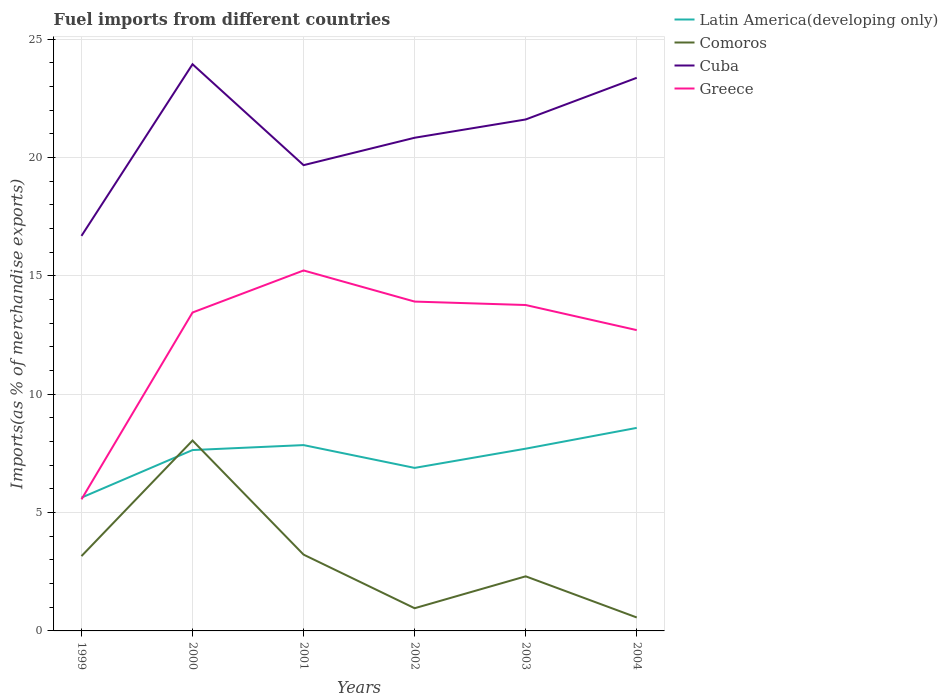How many different coloured lines are there?
Your response must be concise. 4. Does the line corresponding to Greece intersect with the line corresponding to Comoros?
Offer a terse response. No. Is the number of lines equal to the number of legend labels?
Offer a very short reply. Yes. Across all years, what is the maximum percentage of imports to different countries in Latin America(developing only)?
Offer a very short reply. 5.63. What is the total percentage of imports to different countries in Cuba in the graph?
Ensure brevity in your answer.  -1.16. What is the difference between the highest and the second highest percentage of imports to different countries in Greece?
Offer a terse response. 9.67. How many years are there in the graph?
Offer a terse response. 6. Where does the legend appear in the graph?
Provide a succinct answer. Top right. How many legend labels are there?
Make the answer very short. 4. What is the title of the graph?
Give a very brief answer. Fuel imports from different countries. Does "St. Vincent and the Grenadines" appear as one of the legend labels in the graph?
Provide a short and direct response. No. What is the label or title of the Y-axis?
Keep it short and to the point. Imports(as % of merchandise exports). What is the Imports(as % of merchandise exports) in Latin America(developing only) in 1999?
Your answer should be very brief. 5.63. What is the Imports(as % of merchandise exports) of Comoros in 1999?
Offer a terse response. 3.16. What is the Imports(as % of merchandise exports) in Cuba in 1999?
Your answer should be very brief. 16.69. What is the Imports(as % of merchandise exports) in Greece in 1999?
Offer a very short reply. 5.56. What is the Imports(as % of merchandise exports) of Latin America(developing only) in 2000?
Your answer should be compact. 7.64. What is the Imports(as % of merchandise exports) of Comoros in 2000?
Offer a terse response. 8.04. What is the Imports(as % of merchandise exports) of Cuba in 2000?
Give a very brief answer. 23.94. What is the Imports(as % of merchandise exports) of Greece in 2000?
Offer a terse response. 13.45. What is the Imports(as % of merchandise exports) in Latin America(developing only) in 2001?
Your answer should be compact. 7.85. What is the Imports(as % of merchandise exports) in Comoros in 2001?
Offer a terse response. 3.22. What is the Imports(as % of merchandise exports) of Cuba in 2001?
Provide a succinct answer. 19.68. What is the Imports(as % of merchandise exports) of Greece in 2001?
Your answer should be very brief. 15.23. What is the Imports(as % of merchandise exports) of Latin America(developing only) in 2002?
Keep it short and to the point. 6.89. What is the Imports(as % of merchandise exports) in Comoros in 2002?
Provide a short and direct response. 0.96. What is the Imports(as % of merchandise exports) in Cuba in 2002?
Your answer should be compact. 20.84. What is the Imports(as % of merchandise exports) in Greece in 2002?
Give a very brief answer. 13.91. What is the Imports(as % of merchandise exports) of Latin America(developing only) in 2003?
Your response must be concise. 7.7. What is the Imports(as % of merchandise exports) of Comoros in 2003?
Keep it short and to the point. 2.31. What is the Imports(as % of merchandise exports) in Cuba in 2003?
Offer a very short reply. 21.61. What is the Imports(as % of merchandise exports) of Greece in 2003?
Provide a short and direct response. 13.77. What is the Imports(as % of merchandise exports) in Latin America(developing only) in 2004?
Your answer should be very brief. 8.58. What is the Imports(as % of merchandise exports) in Comoros in 2004?
Make the answer very short. 0.57. What is the Imports(as % of merchandise exports) of Cuba in 2004?
Offer a very short reply. 23.37. What is the Imports(as % of merchandise exports) in Greece in 2004?
Provide a succinct answer. 12.71. Across all years, what is the maximum Imports(as % of merchandise exports) in Latin America(developing only)?
Ensure brevity in your answer.  8.58. Across all years, what is the maximum Imports(as % of merchandise exports) of Comoros?
Give a very brief answer. 8.04. Across all years, what is the maximum Imports(as % of merchandise exports) in Cuba?
Keep it short and to the point. 23.94. Across all years, what is the maximum Imports(as % of merchandise exports) of Greece?
Your answer should be compact. 15.23. Across all years, what is the minimum Imports(as % of merchandise exports) in Latin America(developing only)?
Your response must be concise. 5.63. Across all years, what is the minimum Imports(as % of merchandise exports) of Comoros?
Provide a short and direct response. 0.57. Across all years, what is the minimum Imports(as % of merchandise exports) of Cuba?
Keep it short and to the point. 16.69. Across all years, what is the minimum Imports(as % of merchandise exports) of Greece?
Your response must be concise. 5.56. What is the total Imports(as % of merchandise exports) of Latin America(developing only) in the graph?
Make the answer very short. 44.29. What is the total Imports(as % of merchandise exports) in Comoros in the graph?
Offer a very short reply. 18.26. What is the total Imports(as % of merchandise exports) in Cuba in the graph?
Offer a terse response. 126.12. What is the total Imports(as % of merchandise exports) of Greece in the graph?
Offer a terse response. 74.63. What is the difference between the Imports(as % of merchandise exports) in Latin America(developing only) in 1999 and that in 2000?
Your answer should be compact. -2.01. What is the difference between the Imports(as % of merchandise exports) of Comoros in 1999 and that in 2000?
Your answer should be compact. -4.88. What is the difference between the Imports(as % of merchandise exports) in Cuba in 1999 and that in 2000?
Keep it short and to the point. -7.25. What is the difference between the Imports(as % of merchandise exports) in Greece in 1999 and that in 2000?
Ensure brevity in your answer.  -7.89. What is the difference between the Imports(as % of merchandise exports) of Latin America(developing only) in 1999 and that in 2001?
Offer a very short reply. -2.22. What is the difference between the Imports(as % of merchandise exports) of Comoros in 1999 and that in 2001?
Your answer should be very brief. -0.06. What is the difference between the Imports(as % of merchandise exports) in Cuba in 1999 and that in 2001?
Keep it short and to the point. -2.99. What is the difference between the Imports(as % of merchandise exports) in Greece in 1999 and that in 2001?
Your answer should be very brief. -9.67. What is the difference between the Imports(as % of merchandise exports) of Latin America(developing only) in 1999 and that in 2002?
Provide a succinct answer. -1.26. What is the difference between the Imports(as % of merchandise exports) in Comoros in 1999 and that in 2002?
Make the answer very short. 2.2. What is the difference between the Imports(as % of merchandise exports) of Cuba in 1999 and that in 2002?
Your answer should be very brief. -4.15. What is the difference between the Imports(as % of merchandise exports) in Greece in 1999 and that in 2002?
Give a very brief answer. -8.36. What is the difference between the Imports(as % of merchandise exports) in Latin America(developing only) in 1999 and that in 2003?
Offer a very short reply. -2.07. What is the difference between the Imports(as % of merchandise exports) of Comoros in 1999 and that in 2003?
Keep it short and to the point. 0.85. What is the difference between the Imports(as % of merchandise exports) of Cuba in 1999 and that in 2003?
Give a very brief answer. -4.92. What is the difference between the Imports(as % of merchandise exports) of Greece in 1999 and that in 2003?
Offer a very short reply. -8.21. What is the difference between the Imports(as % of merchandise exports) in Latin America(developing only) in 1999 and that in 2004?
Provide a succinct answer. -2.95. What is the difference between the Imports(as % of merchandise exports) in Comoros in 1999 and that in 2004?
Make the answer very short. 2.59. What is the difference between the Imports(as % of merchandise exports) in Cuba in 1999 and that in 2004?
Provide a succinct answer. -6.68. What is the difference between the Imports(as % of merchandise exports) in Greece in 1999 and that in 2004?
Your response must be concise. -7.15. What is the difference between the Imports(as % of merchandise exports) of Latin America(developing only) in 2000 and that in 2001?
Provide a short and direct response. -0.21. What is the difference between the Imports(as % of merchandise exports) of Comoros in 2000 and that in 2001?
Keep it short and to the point. 4.82. What is the difference between the Imports(as % of merchandise exports) in Cuba in 2000 and that in 2001?
Make the answer very short. 4.26. What is the difference between the Imports(as % of merchandise exports) in Greece in 2000 and that in 2001?
Offer a very short reply. -1.78. What is the difference between the Imports(as % of merchandise exports) in Latin America(developing only) in 2000 and that in 2002?
Offer a very short reply. 0.75. What is the difference between the Imports(as % of merchandise exports) in Comoros in 2000 and that in 2002?
Offer a very short reply. 7.08. What is the difference between the Imports(as % of merchandise exports) in Cuba in 2000 and that in 2002?
Offer a very short reply. 3.11. What is the difference between the Imports(as % of merchandise exports) in Greece in 2000 and that in 2002?
Your answer should be compact. -0.46. What is the difference between the Imports(as % of merchandise exports) of Latin America(developing only) in 2000 and that in 2003?
Provide a succinct answer. -0.06. What is the difference between the Imports(as % of merchandise exports) of Comoros in 2000 and that in 2003?
Provide a succinct answer. 5.74. What is the difference between the Imports(as % of merchandise exports) of Cuba in 2000 and that in 2003?
Make the answer very short. 2.33. What is the difference between the Imports(as % of merchandise exports) of Greece in 2000 and that in 2003?
Offer a terse response. -0.32. What is the difference between the Imports(as % of merchandise exports) of Latin America(developing only) in 2000 and that in 2004?
Provide a succinct answer. -0.94. What is the difference between the Imports(as % of merchandise exports) of Comoros in 2000 and that in 2004?
Provide a succinct answer. 7.47. What is the difference between the Imports(as % of merchandise exports) of Cuba in 2000 and that in 2004?
Offer a terse response. 0.57. What is the difference between the Imports(as % of merchandise exports) of Greece in 2000 and that in 2004?
Ensure brevity in your answer.  0.74. What is the difference between the Imports(as % of merchandise exports) in Latin America(developing only) in 2001 and that in 2002?
Provide a succinct answer. 0.96. What is the difference between the Imports(as % of merchandise exports) of Comoros in 2001 and that in 2002?
Give a very brief answer. 2.26. What is the difference between the Imports(as % of merchandise exports) of Cuba in 2001 and that in 2002?
Make the answer very short. -1.16. What is the difference between the Imports(as % of merchandise exports) in Greece in 2001 and that in 2002?
Your answer should be very brief. 1.31. What is the difference between the Imports(as % of merchandise exports) in Latin America(developing only) in 2001 and that in 2003?
Provide a short and direct response. 0.15. What is the difference between the Imports(as % of merchandise exports) in Comoros in 2001 and that in 2003?
Your answer should be compact. 0.92. What is the difference between the Imports(as % of merchandise exports) in Cuba in 2001 and that in 2003?
Your answer should be compact. -1.93. What is the difference between the Imports(as % of merchandise exports) of Greece in 2001 and that in 2003?
Provide a succinct answer. 1.46. What is the difference between the Imports(as % of merchandise exports) of Latin America(developing only) in 2001 and that in 2004?
Ensure brevity in your answer.  -0.73. What is the difference between the Imports(as % of merchandise exports) in Comoros in 2001 and that in 2004?
Your answer should be compact. 2.65. What is the difference between the Imports(as % of merchandise exports) of Cuba in 2001 and that in 2004?
Provide a succinct answer. -3.69. What is the difference between the Imports(as % of merchandise exports) in Greece in 2001 and that in 2004?
Offer a terse response. 2.52. What is the difference between the Imports(as % of merchandise exports) of Latin America(developing only) in 2002 and that in 2003?
Your response must be concise. -0.81. What is the difference between the Imports(as % of merchandise exports) of Comoros in 2002 and that in 2003?
Ensure brevity in your answer.  -1.35. What is the difference between the Imports(as % of merchandise exports) of Cuba in 2002 and that in 2003?
Your answer should be very brief. -0.77. What is the difference between the Imports(as % of merchandise exports) in Greece in 2002 and that in 2003?
Offer a terse response. 0.15. What is the difference between the Imports(as % of merchandise exports) in Latin America(developing only) in 2002 and that in 2004?
Your answer should be very brief. -1.69. What is the difference between the Imports(as % of merchandise exports) in Comoros in 2002 and that in 2004?
Make the answer very short. 0.39. What is the difference between the Imports(as % of merchandise exports) in Cuba in 2002 and that in 2004?
Keep it short and to the point. -2.53. What is the difference between the Imports(as % of merchandise exports) in Greece in 2002 and that in 2004?
Your answer should be very brief. 1.21. What is the difference between the Imports(as % of merchandise exports) in Latin America(developing only) in 2003 and that in 2004?
Offer a terse response. -0.88. What is the difference between the Imports(as % of merchandise exports) of Comoros in 2003 and that in 2004?
Make the answer very short. 1.74. What is the difference between the Imports(as % of merchandise exports) in Cuba in 2003 and that in 2004?
Offer a terse response. -1.76. What is the difference between the Imports(as % of merchandise exports) of Greece in 2003 and that in 2004?
Your answer should be compact. 1.06. What is the difference between the Imports(as % of merchandise exports) of Latin America(developing only) in 1999 and the Imports(as % of merchandise exports) of Comoros in 2000?
Provide a short and direct response. -2.41. What is the difference between the Imports(as % of merchandise exports) in Latin America(developing only) in 1999 and the Imports(as % of merchandise exports) in Cuba in 2000?
Give a very brief answer. -18.31. What is the difference between the Imports(as % of merchandise exports) in Latin America(developing only) in 1999 and the Imports(as % of merchandise exports) in Greece in 2000?
Your answer should be compact. -7.82. What is the difference between the Imports(as % of merchandise exports) in Comoros in 1999 and the Imports(as % of merchandise exports) in Cuba in 2000?
Keep it short and to the point. -20.78. What is the difference between the Imports(as % of merchandise exports) of Comoros in 1999 and the Imports(as % of merchandise exports) of Greece in 2000?
Give a very brief answer. -10.29. What is the difference between the Imports(as % of merchandise exports) of Cuba in 1999 and the Imports(as % of merchandise exports) of Greece in 2000?
Make the answer very short. 3.24. What is the difference between the Imports(as % of merchandise exports) of Latin America(developing only) in 1999 and the Imports(as % of merchandise exports) of Comoros in 2001?
Your response must be concise. 2.41. What is the difference between the Imports(as % of merchandise exports) in Latin America(developing only) in 1999 and the Imports(as % of merchandise exports) in Cuba in 2001?
Offer a very short reply. -14.05. What is the difference between the Imports(as % of merchandise exports) of Latin America(developing only) in 1999 and the Imports(as % of merchandise exports) of Greece in 2001?
Ensure brevity in your answer.  -9.6. What is the difference between the Imports(as % of merchandise exports) of Comoros in 1999 and the Imports(as % of merchandise exports) of Cuba in 2001?
Provide a short and direct response. -16.52. What is the difference between the Imports(as % of merchandise exports) in Comoros in 1999 and the Imports(as % of merchandise exports) in Greece in 2001?
Offer a very short reply. -12.07. What is the difference between the Imports(as % of merchandise exports) of Cuba in 1999 and the Imports(as % of merchandise exports) of Greece in 2001?
Your response must be concise. 1.46. What is the difference between the Imports(as % of merchandise exports) of Latin America(developing only) in 1999 and the Imports(as % of merchandise exports) of Comoros in 2002?
Offer a terse response. 4.67. What is the difference between the Imports(as % of merchandise exports) in Latin America(developing only) in 1999 and the Imports(as % of merchandise exports) in Cuba in 2002?
Give a very brief answer. -15.2. What is the difference between the Imports(as % of merchandise exports) in Latin America(developing only) in 1999 and the Imports(as % of merchandise exports) in Greece in 2002?
Your response must be concise. -8.28. What is the difference between the Imports(as % of merchandise exports) of Comoros in 1999 and the Imports(as % of merchandise exports) of Cuba in 2002?
Ensure brevity in your answer.  -17.67. What is the difference between the Imports(as % of merchandise exports) of Comoros in 1999 and the Imports(as % of merchandise exports) of Greece in 2002?
Offer a very short reply. -10.75. What is the difference between the Imports(as % of merchandise exports) of Cuba in 1999 and the Imports(as % of merchandise exports) of Greece in 2002?
Make the answer very short. 2.78. What is the difference between the Imports(as % of merchandise exports) of Latin America(developing only) in 1999 and the Imports(as % of merchandise exports) of Comoros in 2003?
Ensure brevity in your answer.  3.32. What is the difference between the Imports(as % of merchandise exports) in Latin America(developing only) in 1999 and the Imports(as % of merchandise exports) in Cuba in 2003?
Keep it short and to the point. -15.98. What is the difference between the Imports(as % of merchandise exports) of Latin America(developing only) in 1999 and the Imports(as % of merchandise exports) of Greece in 2003?
Make the answer very short. -8.14. What is the difference between the Imports(as % of merchandise exports) in Comoros in 1999 and the Imports(as % of merchandise exports) in Cuba in 2003?
Make the answer very short. -18.45. What is the difference between the Imports(as % of merchandise exports) in Comoros in 1999 and the Imports(as % of merchandise exports) in Greece in 2003?
Make the answer very short. -10.61. What is the difference between the Imports(as % of merchandise exports) in Cuba in 1999 and the Imports(as % of merchandise exports) in Greece in 2003?
Make the answer very short. 2.92. What is the difference between the Imports(as % of merchandise exports) of Latin America(developing only) in 1999 and the Imports(as % of merchandise exports) of Comoros in 2004?
Provide a succinct answer. 5.06. What is the difference between the Imports(as % of merchandise exports) of Latin America(developing only) in 1999 and the Imports(as % of merchandise exports) of Cuba in 2004?
Your answer should be very brief. -17.74. What is the difference between the Imports(as % of merchandise exports) of Latin America(developing only) in 1999 and the Imports(as % of merchandise exports) of Greece in 2004?
Your answer should be very brief. -7.08. What is the difference between the Imports(as % of merchandise exports) in Comoros in 1999 and the Imports(as % of merchandise exports) in Cuba in 2004?
Ensure brevity in your answer.  -20.21. What is the difference between the Imports(as % of merchandise exports) of Comoros in 1999 and the Imports(as % of merchandise exports) of Greece in 2004?
Ensure brevity in your answer.  -9.55. What is the difference between the Imports(as % of merchandise exports) of Cuba in 1999 and the Imports(as % of merchandise exports) of Greece in 2004?
Your answer should be compact. 3.98. What is the difference between the Imports(as % of merchandise exports) in Latin America(developing only) in 2000 and the Imports(as % of merchandise exports) in Comoros in 2001?
Offer a very short reply. 4.42. What is the difference between the Imports(as % of merchandise exports) in Latin America(developing only) in 2000 and the Imports(as % of merchandise exports) in Cuba in 2001?
Your answer should be very brief. -12.04. What is the difference between the Imports(as % of merchandise exports) of Latin America(developing only) in 2000 and the Imports(as % of merchandise exports) of Greece in 2001?
Keep it short and to the point. -7.59. What is the difference between the Imports(as % of merchandise exports) of Comoros in 2000 and the Imports(as % of merchandise exports) of Cuba in 2001?
Keep it short and to the point. -11.63. What is the difference between the Imports(as % of merchandise exports) of Comoros in 2000 and the Imports(as % of merchandise exports) of Greece in 2001?
Offer a terse response. -7.19. What is the difference between the Imports(as % of merchandise exports) of Cuba in 2000 and the Imports(as % of merchandise exports) of Greece in 2001?
Make the answer very short. 8.71. What is the difference between the Imports(as % of merchandise exports) of Latin America(developing only) in 2000 and the Imports(as % of merchandise exports) of Comoros in 2002?
Provide a short and direct response. 6.68. What is the difference between the Imports(as % of merchandise exports) of Latin America(developing only) in 2000 and the Imports(as % of merchandise exports) of Cuba in 2002?
Ensure brevity in your answer.  -13.19. What is the difference between the Imports(as % of merchandise exports) in Latin America(developing only) in 2000 and the Imports(as % of merchandise exports) in Greece in 2002?
Offer a very short reply. -6.27. What is the difference between the Imports(as % of merchandise exports) in Comoros in 2000 and the Imports(as % of merchandise exports) in Cuba in 2002?
Make the answer very short. -12.79. What is the difference between the Imports(as % of merchandise exports) of Comoros in 2000 and the Imports(as % of merchandise exports) of Greece in 2002?
Offer a very short reply. -5.87. What is the difference between the Imports(as % of merchandise exports) of Cuba in 2000 and the Imports(as % of merchandise exports) of Greece in 2002?
Make the answer very short. 10.03. What is the difference between the Imports(as % of merchandise exports) in Latin America(developing only) in 2000 and the Imports(as % of merchandise exports) in Comoros in 2003?
Offer a terse response. 5.33. What is the difference between the Imports(as % of merchandise exports) in Latin America(developing only) in 2000 and the Imports(as % of merchandise exports) in Cuba in 2003?
Ensure brevity in your answer.  -13.97. What is the difference between the Imports(as % of merchandise exports) of Latin America(developing only) in 2000 and the Imports(as % of merchandise exports) of Greece in 2003?
Offer a very short reply. -6.13. What is the difference between the Imports(as % of merchandise exports) in Comoros in 2000 and the Imports(as % of merchandise exports) in Cuba in 2003?
Keep it short and to the point. -13.57. What is the difference between the Imports(as % of merchandise exports) of Comoros in 2000 and the Imports(as % of merchandise exports) of Greece in 2003?
Provide a short and direct response. -5.73. What is the difference between the Imports(as % of merchandise exports) in Cuba in 2000 and the Imports(as % of merchandise exports) in Greece in 2003?
Provide a succinct answer. 10.17. What is the difference between the Imports(as % of merchandise exports) in Latin America(developing only) in 2000 and the Imports(as % of merchandise exports) in Comoros in 2004?
Your answer should be compact. 7.07. What is the difference between the Imports(as % of merchandise exports) of Latin America(developing only) in 2000 and the Imports(as % of merchandise exports) of Cuba in 2004?
Your response must be concise. -15.73. What is the difference between the Imports(as % of merchandise exports) in Latin America(developing only) in 2000 and the Imports(as % of merchandise exports) in Greece in 2004?
Your response must be concise. -5.07. What is the difference between the Imports(as % of merchandise exports) of Comoros in 2000 and the Imports(as % of merchandise exports) of Cuba in 2004?
Your answer should be very brief. -15.33. What is the difference between the Imports(as % of merchandise exports) of Comoros in 2000 and the Imports(as % of merchandise exports) of Greece in 2004?
Your answer should be very brief. -4.67. What is the difference between the Imports(as % of merchandise exports) in Cuba in 2000 and the Imports(as % of merchandise exports) in Greece in 2004?
Make the answer very short. 11.23. What is the difference between the Imports(as % of merchandise exports) of Latin America(developing only) in 2001 and the Imports(as % of merchandise exports) of Comoros in 2002?
Make the answer very short. 6.89. What is the difference between the Imports(as % of merchandise exports) of Latin America(developing only) in 2001 and the Imports(as % of merchandise exports) of Cuba in 2002?
Your answer should be very brief. -12.99. What is the difference between the Imports(as % of merchandise exports) in Latin America(developing only) in 2001 and the Imports(as % of merchandise exports) in Greece in 2002?
Your response must be concise. -6.06. What is the difference between the Imports(as % of merchandise exports) in Comoros in 2001 and the Imports(as % of merchandise exports) in Cuba in 2002?
Keep it short and to the point. -17.61. What is the difference between the Imports(as % of merchandise exports) in Comoros in 2001 and the Imports(as % of merchandise exports) in Greece in 2002?
Make the answer very short. -10.69. What is the difference between the Imports(as % of merchandise exports) of Cuba in 2001 and the Imports(as % of merchandise exports) of Greece in 2002?
Offer a terse response. 5.76. What is the difference between the Imports(as % of merchandise exports) in Latin America(developing only) in 2001 and the Imports(as % of merchandise exports) in Comoros in 2003?
Offer a very short reply. 5.54. What is the difference between the Imports(as % of merchandise exports) of Latin America(developing only) in 2001 and the Imports(as % of merchandise exports) of Cuba in 2003?
Keep it short and to the point. -13.76. What is the difference between the Imports(as % of merchandise exports) of Latin America(developing only) in 2001 and the Imports(as % of merchandise exports) of Greece in 2003?
Give a very brief answer. -5.92. What is the difference between the Imports(as % of merchandise exports) in Comoros in 2001 and the Imports(as % of merchandise exports) in Cuba in 2003?
Provide a succinct answer. -18.39. What is the difference between the Imports(as % of merchandise exports) of Comoros in 2001 and the Imports(as % of merchandise exports) of Greece in 2003?
Offer a terse response. -10.55. What is the difference between the Imports(as % of merchandise exports) of Cuba in 2001 and the Imports(as % of merchandise exports) of Greece in 2003?
Offer a very short reply. 5.91. What is the difference between the Imports(as % of merchandise exports) of Latin America(developing only) in 2001 and the Imports(as % of merchandise exports) of Comoros in 2004?
Provide a succinct answer. 7.28. What is the difference between the Imports(as % of merchandise exports) in Latin America(developing only) in 2001 and the Imports(as % of merchandise exports) in Cuba in 2004?
Ensure brevity in your answer.  -15.52. What is the difference between the Imports(as % of merchandise exports) in Latin America(developing only) in 2001 and the Imports(as % of merchandise exports) in Greece in 2004?
Offer a very short reply. -4.86. What is the difference between the Imports(as % of merchandise exports) of Comoros in 2001 and the Imports(as % of merchandise exports) of Cuba in 2004?
Make the answer very short. -20.15. What is the difference between the Imports(as % of merchandise exports) of Comoros in 2001 and the Imports(as % of merchandise exports) of Greece in 2004?
Make the answer very short. -9.49. What is the difference between the Imports(as % of merchandise exports) of Cuba in 2001 and the Imports(as % of merchandise exports) of Greece in 2004?
Keep it short and to the point. 6.97. What is the difference between the Imports(as % of merchandise exports) in Latin America(developing only) in 2002 and the Imports(as % of merchandise exports) in Comoros in 2003?
Your answer should be compact. 4.58. What is the difference between the Imports(as % of merchandise exports) in Latin America(developing only) in 2002 and the Imports(as % of merchandise exports) in Cuba in 2003?
Provide a short and direct response. -14.72. What is the difference between the Imports(as % of merchandise exports) in Latin America(developing only) in 2002 and the Imports(as % of merchandise exports) in Greece in 2003?
Provide a short and direct response. -6.88. What is the difference between the Imports(as % of merchandise exports) of Comoros in 2002 and the Imports(as % of merchandise exports) of Cuba in 2003?
Make the answer very short. -20.65. What is the difference between the Imports(as % of merchandise exports) in Comoros in 2002 and the Imports(as % of merchandise exports) in Greece in 2003?
Your answer should be compact. -12.81. What is the difference between the Imports(as % of merchandise exports) of Cuba in 2002 and the Imports(as % of merchandise exports) of Greece in 2003?
Keep it short and to the point. 7.07. What is the difference between the Imports(as % of merchandise exports) of Latin America(developing only) in 2002 and the Imports(as % of merchandise exports) of Comoros in 2004?
Your response must be concise. 6.32. What is the difference between the Imports(as % of merchandise exports) in Latin America(developing only) in 2002 and the Imports(as % of merchandise exports) in Cuba in 2004?
Offer a terse response. -16.48. What is the difference between the Imports(as % of merchandise exports) in Latin America(developing only) in 2002 and the Imports(as % of merchandise exports) in Greece in 2004?
Your response must be concise. -5.82. What is the difference between the Imports(as % of merchandise exports) of Comoros in 2002 and the Imports(as % of merchandise exports) of Cuba in 2004?
Offer a terse response. -22.41. What is the difference between the Imports(as % of merchandise exports) in Comoros in 2002 and the Imports(as % of merchandise exports) in Greece in 2004?
Keep it short and to the point. -11.75. What is the difference between the Imports(as % of merchandise exports) of Cuba in 2002 and the Imports(as % of merchandise exports) of Greece in 2004?
Your response must be concise. 8.13. What is the difference between the Imports(as % of merchandise exports) of Latin America(developing only) in 2003 and the Imports(as % of merchandise exports) of Comoros in 2004?
Ensure brevity in your answer.  7.13. What is the difference between the Imports(as % of merchandise exports) in Latin America(developing only) in 2003 and the Imports(as % of merchandise exports) in Cuba in 2004?
Provide a short and direct response. -15.67. What is the difference between the Imports(as % of merchandise exports) of Latin America(developing only) in 2003 and the Imports(as % of merchandise exports) of Greece in 2004?
Your answer should be very brief. -5.01. What is the difference between the Imports(as % of merchandise exports) in Comoros in 2003 and the Imports(as % of merchandise exports) in Cuba in 2004?
Offer a terse response. -21.06. What is the difference between the Imports(as % of merchandise exports) of Comoros in 2003 and the Imports(as % of merchandise exports) of Greece in 2004?
Keep it short and to the point. -10.4. What is the difference between the Imports(as % of merchandise exports) of Cuba in 2003 and the Imports(as % of merchandise exports) of Greece in 2004?
Offer a very short reply. 8.9. What is the average Imports(as % of merchandise exports) of Latin America(developing only) per year?
Make the answer very short. 7.38. What is the average Imports(as % of merchandise exports) in Comoros per year?
Provide a succinct answer. 3.04. What is the average Imports(as % of merchandise exports) in Cuba per year?
Your answer should be compact. 21.02. What is the average Imports(as % of merchandise exports) in Greece per year?
Ensure brevity in your answer.  12.44. In the year 1999, what is the difference between the Imports(as % of merchandise exports) in Latin America(developing only) and Imports(as % of merchandise exports) in Comoros?
Your response must be concise. 2.47. In the year 1999, what is the difference between the Imports(as % of merchandise exports) in Latin America(developing only) and Imports(as % of merchandise exports) in Cuba?
Give a very brief answer. -11.06. In the year 1999, what is the difference between the Imports(as % of merchandise exports) of Latin America(developing only) and Imports(as % of merchandise exports) of Greece?
Provide a short and direct response. 0.07. In the year 1999, what is the difference between the Imports(as % of merchandise exports) of Comoros and Imports(as % of merchandise exports) of Cuba?
Offer a very short reply. -13.53. In the year 1999, what is the difference between the Imports(as % of merchandise exports) in Comoros and Imports(as % of merchandise exports) in Greece?
Keep it short and to the point. -2.4. In the year 1999, what is the difference between the Imports(as % of merchandise exports) in Cuba and Imports(as % of merchandise exports) in Greece?
Give a very brief answer. 11.13. In the year 2000, what is the difference between the Imports(as % of merchandise exports) in Latin America(developing only) and Imports(as % of merchandise exports) in Comoros?
Give a very brief answer. -0.4. In the year 2000, what is the difference between the Imports(as % of merchandise exports) of Latin America(developing only) and Imports(as % of merchandise exports) of Cuba?
Make the answer very short. -16.3. In the year 2000, what is the difference between the Imports(as % of merchandise exports) of Latin America(developing only) and Imports(as % of merchandise exports) of Greece?
Your answer should be very brief. -5.81. In the year 2000, what is the difference between the Imports(as % of merchandise exports) in Comoros and Imports(as % of merchandise exports) in Cuba?
Offer a terse response. -15.9. In the year 2000, what is the difference between the Imports(as % of merchandise exports) in Comoros and Imports(as % of merchandise exports) in Greece?
Give a very brief answer. -5.41. In the year 2000, what is the difference between the Imports(as % of merchandise exports) of Cuba and Imports(as % of merchandise exports) of Greece?
Ensure brevity in your answer.  10.49. In the year 2001, what is the difference between the Imports(as % of merchandise exports) in Latin America(developing only) and Imports(as % of merchandise exports) in Comoros?
Your answer should be compact. 4.63. In the year 2001, what is the difference between the Imports(as % of merchandise exports) in Latin America(developing only) and Imports(as % of merchandise exports) in Cuba?
Offer a terse response. -11.83. In the year 2001, what is the difference between the Imports(as % of merchandise exports) in Latin America(developing only) and Imports(as % of merchandise exports) in Greece?
Provide a succinct answer. -7.38. In the year 2001, what is the difference between the Imports(as % of merchandise exports) of Comoros and Imports(as % of merchandise exports) of Cuba?
Offer a very short reply. -16.45. In the year 2001, what is the difference between the Imports(as % of merchandise exports) in Comoros and Imports(as % of merchandise exports) in Greece?
Ensure brevity in your answer.  -12.01. In the year 2001, what is the difference between the Imports(as % of merchandise exports) in Cuba and Imports(as % of merchandise exports) in Greece?
Offer a terse response. 4.45. In the year 2002, what is the difference between the Imports(as % of merchandise exports) in Latin America(developing only) and Imports(as % of merchandise exports) in Comoros?
Your response must be concise. 5.93. In the year 2002, what is the difference between the Imports(as % of merchandise exports) in Latin America(developing only) and Imports(as % of merchandise exports) in Cuba?
Provide a short and direct response. -13.95. In the year 2002, what is the difference between the Imports(as % of merchandise exports) of Latin America(developing only) and Imports(as % of merchandise exports) of Greece?
Provide a short and direct response. -7.03. In the year 2002, what is the difference between the Imports(as % of merchandise exports) in Comoros and Imports(as % of merchandise exports) in Cuba?
Your answer should be compact. -19.88. In the year 2002, what is the difference between the Imports(as % of merchandise exports) in Comoros and Imports(as % of merchandise exports) in Greece?
Offer a very short reply. -12.96. In the year 2002, what is the difference between the Imports(as % of merchandise exports) in Cuba and Imports(as % of merchandise exports) in Greece?
Make the answer very short. 6.92. In the year 2003, what is the difference between the Imports(as % of merchandise exports) in Latin America(developing only) and Imports(as % of merchandise exports) in Comoros?
Your response must be concise. 5.39. In the year 2003, what is the difference between the Imports(as % of merchandise exports) in Latin America(developing only) and Imports(as % of merchandise exports) in Cuba?
Offer a very short reply. -13.91. In the year 2003, what is the difference between the Imports(as % of merchandise exports) of Latin America(developing only) and Imports(as % of merchandise exports) of Greece?
Offer a very short reply. -6.07. In the year 2003, what is the difference between the Imports(as % of merchandise exports) in Comoros and Imports(as % of merchandise exports) in Cuba?
Keep it short and to the point. -19.3. In the year 2003, what is the difference between the Imports(as % of merchandise exports) of Comoros and Imports(as % of merchandise exports) of Greece?
Keep it short and to the point. -11.46. In the year 2003, what is the difference between the Imports(as % of merchandise exports) of Cuba and Imports(as % of merchandise exports) of Greece?
Keep it short and to the point. 7.84. In the year 2004, what is the difference between the Imports(as % of merchandise exports) in Latin America(developing only) and Imports(as % of merchandise exports) in Comoros?
Give a very brief answer. 8.01. In the year 2004, what is the difference between the Imports(as % of merchandise exports) of Latin America(developing only) and Imports(as % of merchandise exports) of Cuba?
Give a very brief answer. -14.79. In the year 2004, what is the difference between the Imports(as % of merchandise exports) of Latin America(developing only) and Imports(as % of merchandise exports) of Greece?
Keep it short and to the point. -4.13. In the year 2004, what is the difference between the Imports(as % of merchandise exports) in Comoros and Imports(as % of merchandise exports) in Cuba?
Keep it short and to the point. -22.8. In the year 2004, what is the difference between the Imports(as % of merchandise exports) of Comoros and Imports(as % of merchandise exports) of Greece?
Provide a succinct answer. -12.14. In the year 2004, what is the difference between the Imports(as % of merchandise exports) in Cuba and Imports(as % of merchandise exports) in Greece?
Your answer should be very brief. 10.66. What is the ratio of the Imports(as % of merchandise exports) in Latin America(developing only) in 1999 to that in 2000?
Make the answer very short. 0.74. What is the ratio of the Imports(as % of merchandise exports) in Comoros in 1999 to that in 2000?
Ensure brevity in your answer.  0.39. What is the ratio of the Imports(as % of merchandise exports) in Cuba in 1999 to that in 2000?
Your answer should be compact. 0.7. What is the ratio of the Imports(as % of merchandise exports) of Greece in 1999 to that in 2000?
Offer a terse response. 0.41. What is the ratio of the Imports(as % of merchandise exports) in Latin America(developing only) in 1999 to that in 2001?
Your answer should be very brief. 0.72. What is the ratio of the Imports(as % of merchandise exports) of Comoros in 1999 to that in 2001?
Provide a short and direct response. 0.98. What is the ratio of the Imports(as % of merchandise exports) in Cuba in 1999 to that in 2001?
Give a very brief answer. 0.85. What is the ratio of the Imports(as % of merchandise exports) in Greece in 1999 to that in 2001?
Give a very brief answer. 0.36. What is the ratio of the Imports(as % of merchandise exports) in Latin America(developing only) in 1999 to that in 2002?
Offer a terse response. 0.82. What is the ratio of the Imports(as % of merchandise exports) of Comoros in 1999 to that in 2002?
Provide a short and direct response. 3.3. What is the ratio of the Imports(as % of merchandise exports) in Cuba in 1999 to that in 2002?
Your answer should be very brief. 0.8. What is the ratio of the Imports(as % of merchandise exports) of Greece in 1999 to that in 2002?
Your answer should be compact. 0.4. What is the ratio of the Imports(as % of merchandise exports) of Latin America(developing only) in 1999 to that in 2003?
Your response must be concise. 0.73. What is the ratio of the Imports(as % of merchandise exports) of Comoros in 1999 to that in 2003?
Your answer should be compact. 1.37. What is the ratio of the Imports(as % of merchandise exports) in Cuba in 1999 to that in 2003?
Keep it short and to the point. 0.77. What is the ratio of the Imports(as % of merchandise exports) of Greece in 1999 to that in 2003?
Give a very brief answer. 0.4. What is the ratio of the Imports(as % of merchandise exports) in Latin America(developing only) in 1999 to that in 2004?
Offer a very short reply. 0.66. What is the ratio of the Imports(as % of merchandise exports) in Comoros in 1999 to that in 2004?
Provide a succinct answer. 5.56. What is the ratio of the Imports(as % of merchandise exports) in Cuba in 1999 to that in 2004?
Your answer should be compact. 0.71. What is the ratio of the Imports(as % of merchandise exports) of Greece in 1999 to that in 2004?
Your response must be concise. 0.44. What is the ratio of the Imports(as % of merchandise exports) of Latin America(developing only) in 2000 to that in 2001?
Keep it short and to the point. 0.97. What is the ratio of the Imports(as % of merchandise exports) in Comoros in 2000 to that in 2001?
Give a very brief answer. 2.5. What is the ratio of the Imports(as % of merchandise exports) in Cuba in 2000 to that in 2001?
Give a very brief answer. 1.22. What is the ratio of the Imports(as % of merchandise exports) in Greece in 2000 to that in 2001?
Make the answer very short. 0.88. What is the ratio of the Imports(as % of merchandise exports) in Latin America(developing only) in 2000 to that in 2002?
Ensure brevity in your answer.  1.11. What is the ratio of the Imports(as % of merchandise exports) in Comoros in 2000 to that in 2002?
Ensure brevity in your answer.  8.39. What is the ratio of the Imports(as % of merchandise exports) of Cuba in 2000 to that in 2002?
Your answer should be compact. 1.15. What is the ratio of the Imports(as % of merchandise exports) of Greece in 2000 to that in 2002?
Ensure brevity in your answer.  0.97. What is the ratio of the Imports(as % of merchandise exports) of Comoros in 2000 to that in 2003?
Your answer should be very brief. 3.49. What is the ratio of the Imports(as % of merchandise exports) of Cuba in 2000 to that in 2003?
Provide a short and direct response. 1.11. What is the ratio of the Imports(as % of merchandise exports) in Greece in 2000 to that in 2003?
Make the answer very short. 0.98. What is the ratio of the Imports(as % of merchandise exports) in Latin America(developing only) in 2000 to that in 2004?
Give a very brief answer. 0.89. What is the ratio of the Imports(as % of merchandise exports) of Comoros in 2000 to that in 2004?
Offer a terse response. 14.15. What is the ratio of the Imports(as % of merchandise exports) in Cuba in 2000 to that in 2004?
Offer a very short reply. 1.02. What is the ratio of the Imports(as % of merchandise exports) of Greece in 2000 to that in 2004?
Make the answer very short. 1.06. What is the ratio of the Imports(as % of merchandise exports) of Latin America(developing only) in 2001 to that in 2002?
Your answer should be very brief. 1.14. What is the ratio of the Imports(as % of merchandise exports) of Comoros in 2001 to that in 2002?
Provide a short and direct response. 3.36. What is the ratio of the Imports(as % of merchandise exports) in Greece in 2001 to that in 2002?
Offer a terse response. 1.09. What is the ratio of the Imports(as % of merchandise exports) of Latin America(developing only) in 2001 to that in 2003?
Your answer should be compact. 1.02. What is the ratio of the Imports(as % of merchandise exports) of Comoros in 2001 to that in 2003?
Provide a short and direct response. 1.4. What is the ratio of the Imports(as % of merchandise exports) in Cuba in 2001 to that in 2003?
Ensure brevity in your answer.  0.91. What is the ratio of the Imports(as % of merchandise exports) in Greece in 2001 to that in 2003?
Provide a short and direct response. 1.11. What is the ratio of the Imports(as % of merchandise exports) of Latin America(developing only) in 2001 to that in 2004?
Your response must be concise. 0.92. What is the ratio of the Imports(as % of merchandise exports) in Comoros in 2001 to that in 2004?
Provide a succinct answer. 5.67. What is the ratio of the Imports(as % of merchandise exports) in Cuba in 2001 to that in 2004?
Your answer should be very brief. 0.84. What is the ratio of the Imports(as % of merchandise exports) of Greece in 2001 to that in 2004?
Offer a very short reply. 1.2. What is the ratio of the Imports(as % of merchandise exports) in Latin America(developing only) in 2002 to that in 2003?
Offer a terse response. 0.89. What is the ratio of the Imports(as % of merchandise exports) of Comoros in 2002 to that in 2003?
Your answer should be compact. 0.42. What is the ratio of the Imports(as % of merchandise exports) of Cuba in 2002 to that in 2003?
Your response must be concise. 0.96. What is the ratio of the Imports(as % of merchandise exports) in Greece in 2002 to that in 2003?
Offer a very short reply. 1.01. What is the ratio of the Imports(as % of merchandise exports) in Latin America(developing only) in 2002 to that in 2004?
Your answer should be very brief. 0.8. What is the ratio of the Imports(as % of merchandise exports) in Comoros in 2002 to that in 2004?
Your answer should be compact. 1.69. What is the ratio of the Imports(as % of merchandise exports) in Cuba in 2002 to that in 2004?
Ensure brevity in your answer.  0.89. What is the ratio of the Imports(as % of merchandise exports) of Greece in 2002 to that in 2004?
Provide a short and direct response. 1.09. What is the ratio of the Imports(as % of merchandise exports) in Latin America(developing only) in 2003 to that in 2004?
Your answer should be very brief. 0.9. What is the ratio of the Imports(as % of merchandise exports) of Comoros in 2003 to that in 2004?
Make the answer very short. 4.06. What is the ratio of the Imports(as % of merchandise exports) in Cuba in 2003 to that in 2004?
Offer a very short reply. 0.92. What is the ratio of the Imports(as % of merchandise exports) of Greece in 2003 to that in 2004?
Your answer should be very brief. 1.08. What is the difference between the highest and the second highest Imports(as % of merchandise exports) of Latin America(developing only)?
Provide a short and direct response. 0.73. What is the difference between the highest and the second highest Imports(as % of merchandise exports) of Comoros?
Ensure brevity in your answer.  4.82. What is the difference between the highest and the second highest Imports(as % of merchandise exports) in Cuba?
Make the answer very short. 0.57. What is the difference between the highest and the second highest Imports(as % of merchandise exports) of Greece?
Give a very brief answer. 1.31. What is the difference between the highest and the lowest Imports(as % of merchandise exports) of Latin America(developing only)?
Keep it short and to the point. 2.95. What is the difference between the highest and the lowest Imports(as % of merchandise exports) of Comoros?
Offer a very short reply. 7.47. What is the difference between the highest and the lowest Imports(as % of merchandise exports) in Cuba?
Keep it short and to the point. 7.25. What is the difference between the highest and the lowest Imports(as % of merchandise exports) of Greece?
Offer a terse response. 9.67. 